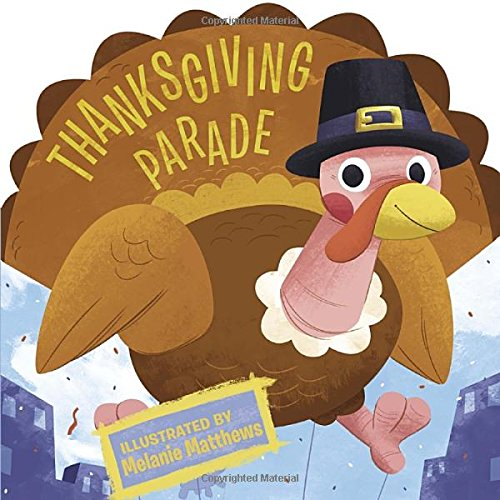Who is the author of this book? The cover indicates that the book, 'Thanksgiving Parade,' is illustrated by Melanie Matthews. 